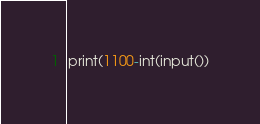Convert code to text. <code><loc_0><loc_0><loc_500><loc_500><_Python_>print(1100-int(input())</code> 